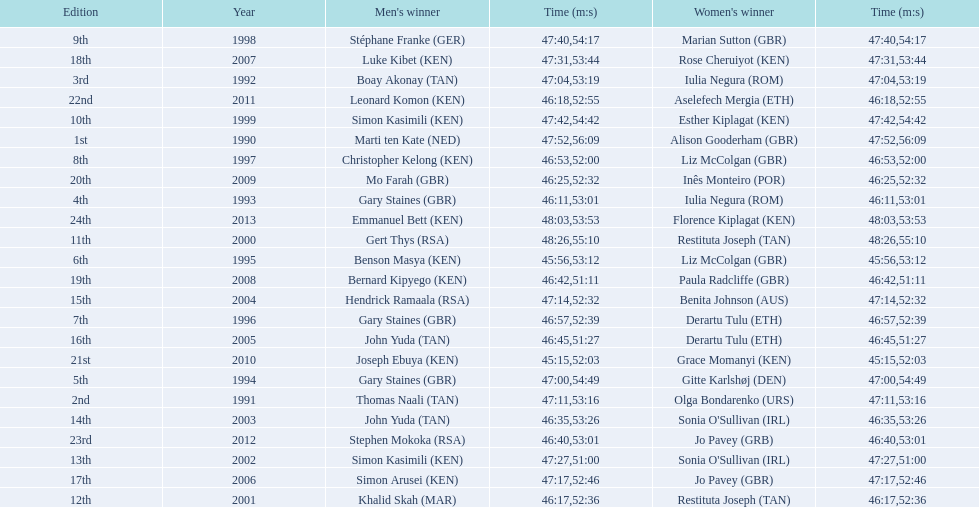What is the number of times, between 1990 and 2013, for britain not to win the men's or women's bupa great south run? 13. 